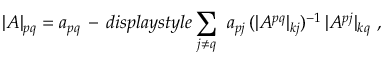<formula> <loc_0><loc_0><loc_500><loc_500>| A | _ { p q } = a _ { p q } \, - \, d i s p l a y s t y l e \sum _ { j \not = q } \ a _ { p j } \, ( | A ^ { p q } | _ { k j } ) ^ { - 1 } \, | A ^ { p j } | _ { k q } \ ,</formula> 